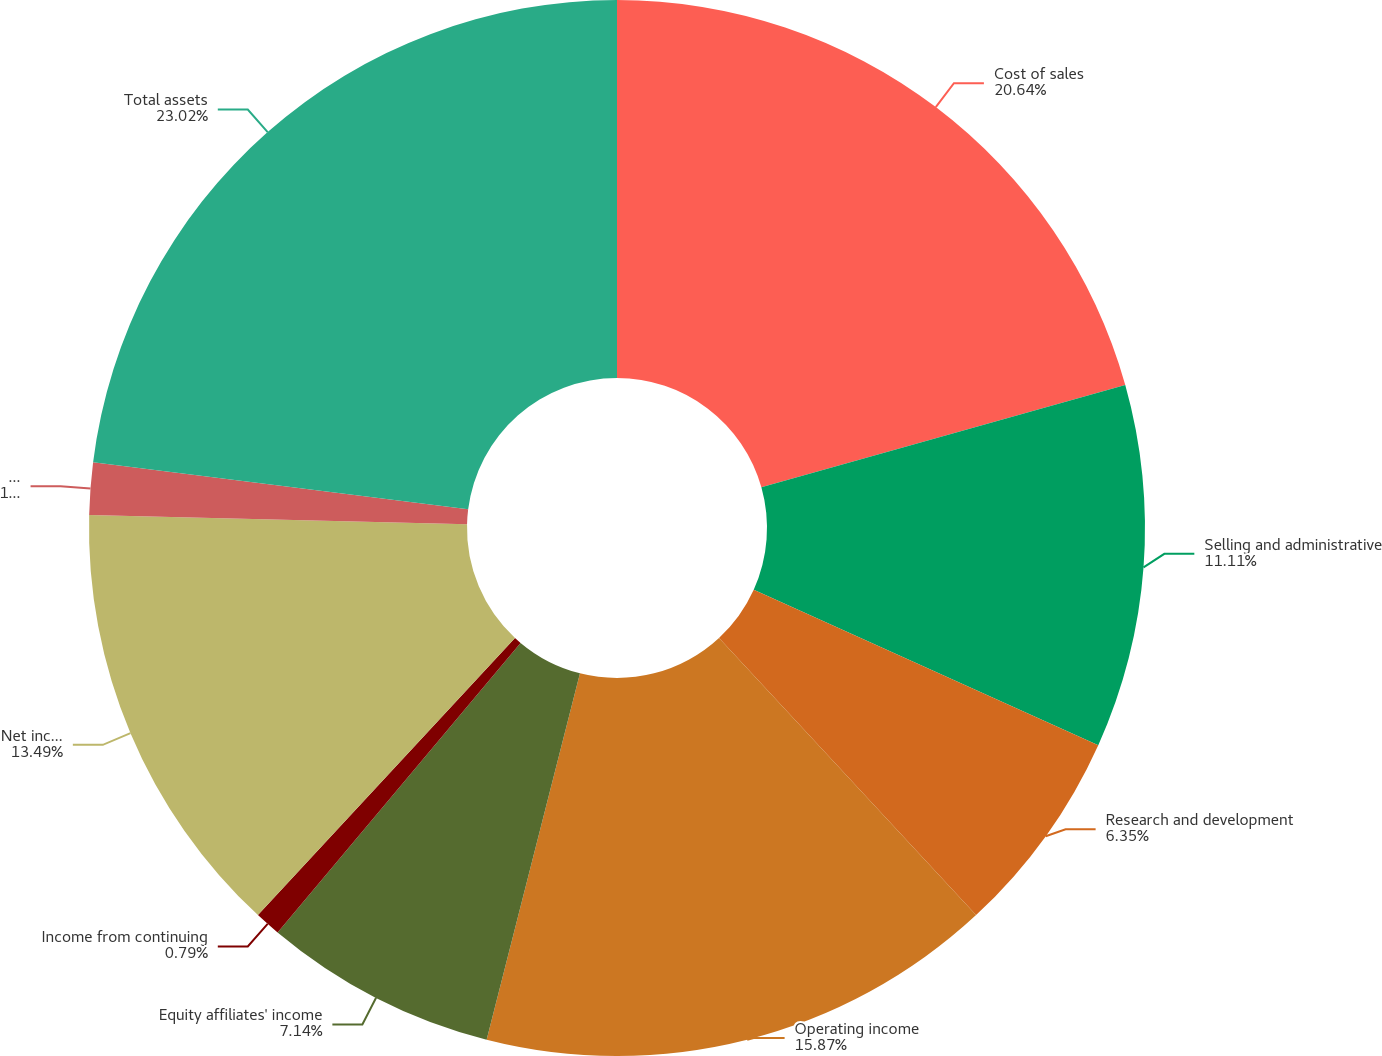<chart> <loc_0><loc_0><loc_500><loc_500><pie_chart><fcel>Cost of sales<fcel>Selling and administrative<fcel>Research and development<fcel>Operating income<fcel>Equity affiliates' income<fcel>Income from continuing<fcel>Net income attributable to Air<fcel>Net income<fcel>Total assets<nl><fcel>20.63%<fcel>11.11%<fcel>6.35%<fcel>15.87%<fcel>7.14%<fcel>0.79%<fcel>13.49%<fcel>1.59%<fcel>23.01%<nl></chart> 